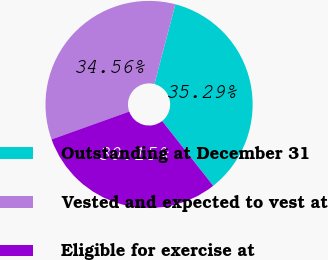Convert chart to OTSL. <chart><loc_0><loc_0><loc_500><loc_500><pie_chart><fcel>Outstanding at December 31<fcel>Vested and expected to vest at<fcel>Eligible for exercise at<nl><fcel>35.29%<fcel>34.56%<fcel>30.15%<nl></chart> 